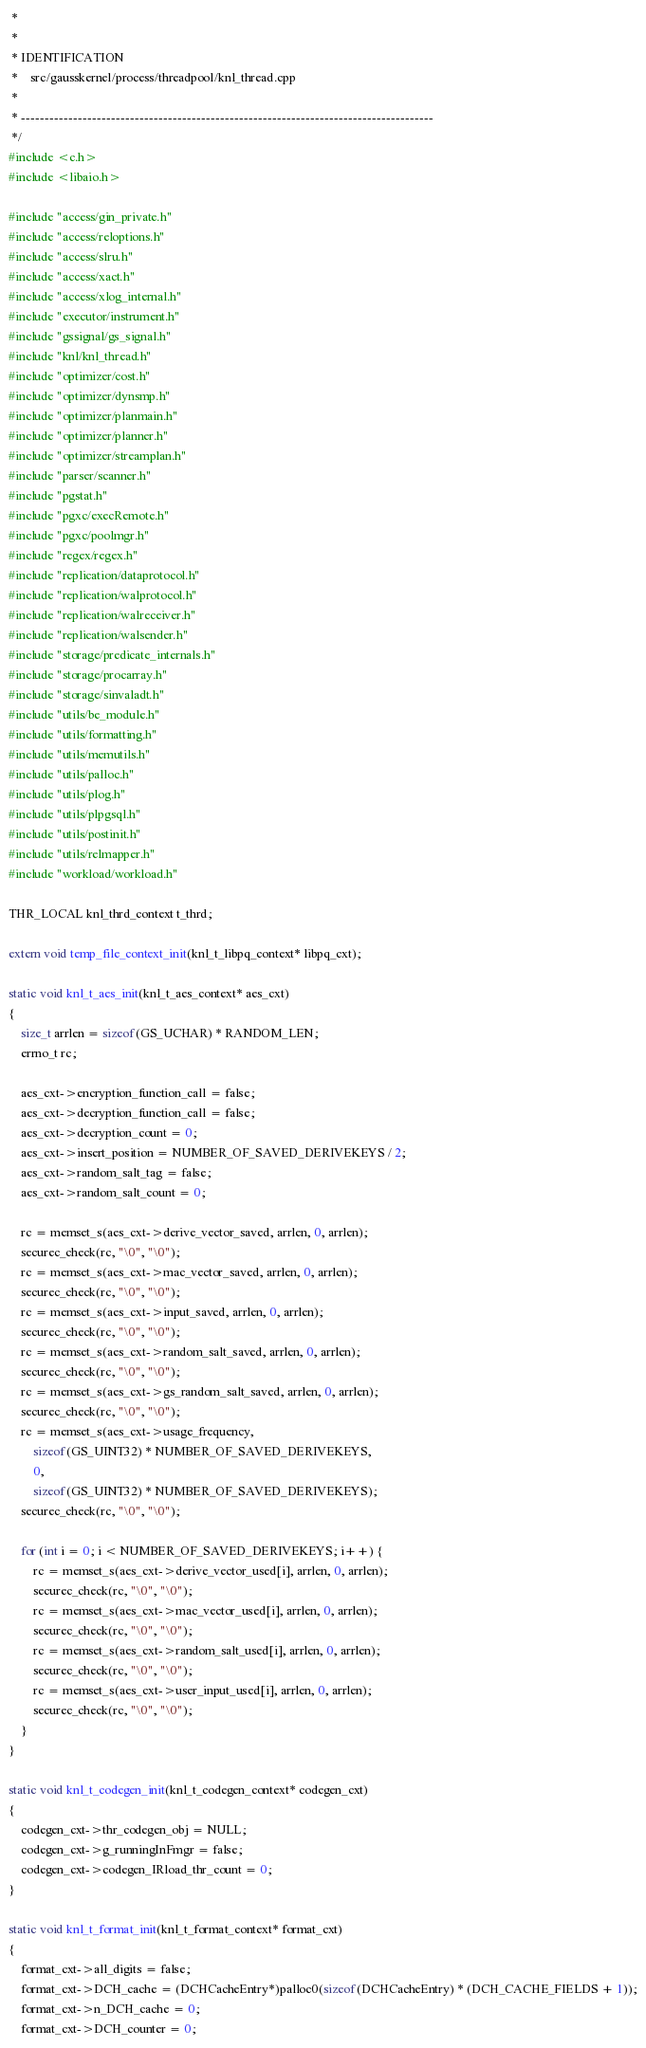Convert code to text. <code><loc_0><loc_0><loc_500><loc_500><_C++_> *
 *
 * IDENTIFICATION
 *    src/gausskernel/process/threadpool/knl_thread.cpp
 *
 * ---------------------------------------------------------------------------------------
 */
#include <c.h>
#include <libaio.h>

#include "access/gin_private.h"
#include "access/reloptions.h"
#include "access/slru.h"
#include "access/xact.h"
#include "access/xlog_internal.h"
#include "executor/instrument.h"
#include "gssignal/gs_signal.h"
#include "knl/knl_thread.h"
#include "optimizer/cost.h"
#include "optimizer/dynsmp.h"
#include "optimizer/planmain.h"
#include "optimizer/planner.h"
#include "optimizer/streamplan.h"
#include "parser/scanner.h"
#include "pgstat.h"
#include "pgxc/execRemote.h"
#include "pgxc/poolmgr.h"
#include "regex/regex.h"
#include "replication/dataprotocol.h"
#include "replication/walprotocol.h"
#include "replication/walreceiver.h"
#include "replication/walsender.h"
#include "storage/predicate_internals.h"
#include "storage/procarray.h"
#include "storage/sinvaladt.h"
#include "utils/be_module.h"
#include "utils/formatting.h"
#include "utils/memutils.h"
#include "utils/palloc.h"
#include "utils/plog.h"
#include "utils/plpgsql.h"
#include "utils/postinit.h"
#include "utils/relmapper.h"
#include "workload/workload.h"

THR_LOCAL knl_thrd_context t_thrd;

extern void temp_file_context_init(knl_t_libpq_context* libpq_cxt);

static void knl_t_aes_init(knl_t_aes_context* aes_cxt)
{
    size_t arrlen = sizeof(GS_UCHAR) * RANDOM_LEN;
    errno_t rc;

    aes_cxt->encryption_function_call = false;
    aes_cxt->decryption_function_call = false;
    aes_cxt->decryption_count = 0;
    aes_cxt->insert_position = NUMBER_OF_SAVED_DERIVEKEYS / 2;
    aes_cxt->random_salt_tag = false;
    aes_cxt->random_salt_count = 0;

    rc = memset_s(aes_cxt->derive_vector_saved, arrlen, 0, arrlen);
    securec_check(rc, "\0", "\0");
    rc = memset_s(aes_cxt->mac_vector_saved, arrlen, 0, arrlen);
    securec_check(rc, "\0", "\0");
    rc = memset_s(aes_cxt->input_saved, arrlen, 0, arrlen);
    securec_check(rc, "\0", "\0");
    rc = memset_s(aes_cxt->random_salt_saved, arrlen, 0, arrlen);
    securec_check(rc, "\0", "\0");
    rc = memset_s(aes_cxt->gs_random_salt_saved, arrlen, 0, arrlen);
    securec_check(rc, "\0", "\0");
    rc = memset_s(aes_cxt->usage_frequency,
        sizeof(GS_UINT32) * NUMBER_OF_SAVED_DERIVEKEYS,
        0,
        sizeof(GS_UINT32) * NUMBER_OF_SAVED_DERIVEKEYS);
    securec_check(rc, "\0", "\0");

    for (int i = 0; i < NUMBER_OF_SAVED_DERIVEKEYS; i++) {
        rc = memset_s(aes_cxt->derive_vector_used[i], arrlen, 0, arrlen);
        securec_check(rc, "\0", "\0");
        rc = memset_s(aes_cxt->mac_vector_used[i], arrlen, 0, arrlen);
        securec_check(rc, "\0", "\0");
        rc = memset_s(aes_cxt->random_salt_used[i], arrlen, 0, arrlen);
        securec_check(rc, "\0", "\0");
        rc = memset_s(aes_cxt->user_input_used[i], arrlen, 0, arrlen);
        securec_check(rc, "\0", "\0");
    }
}

static void knl_t_codegen_init(knl_t_codegen_context* codegen_cxt)
{
    codegen_cxt->thr_codegen_obj = NULL;
    codegen_cxt->g_runningInFmgr = false;
    codegen_cxt->codegen_IRload_thr_count = 0;
}

static void knl_t_format_init(knl_t_format_context* format_cxt)
{
    format_cxt->all_digits = false;
    format_cxt->DCH_cache = (DCHCacheEntry*)palloc0(sizeof(DCHCacheEntry) * (DCH_CACHE_FIELDS + 1));
    format_cxt->n_DCH_cache = 0;
    format_cxt->DCH_counter = 0;</code> 